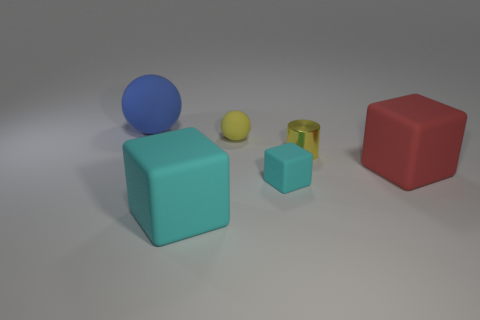What number of tiny spheres are the same color as the shiny cylinder?
Keep it short and to the point. 1. Are there any other things that are the same material as the tiny cyan object?
Provide a succinct answer. Yes. Is the number of large red matte things that are left of the tiny metallic cylinder less than the number of tiny gray metallic objects?
Ensure brevity in your answer.  No. The big rubber block that is behind the big cube that is on the left side of the metal cylinder is what color?
Make the answer very short. Red. There is a yellow thing on the right side of the matte ball that is to the right of the large rubber cube in front of the red thing; what size is it?
Keep it short and to the point. Small. Is the number of yellow rubber objects right of the small yellow rubber thing less than the number of yellow objects that are behind the small cyan cube?
Offer a terse response. Yes. How many other big spheres are the same material as the blue ball?
Your response must be concise. 0. There is a large block in front of the tiny matte thing in front of the big red matte cube; is there a big cyan cube left of it?
Your answer should be very brief. No. What shape is the big blue object that is the same material as the red thing?
Your response must be concise. Sphere. Are there more large objects than yellow rubber blocks?
Ensure brevity in your answer.  Yes. 